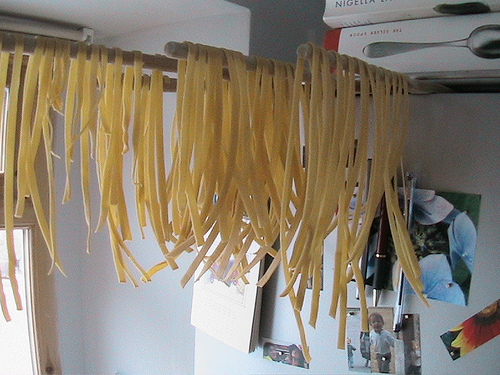<image>
Is the noodles on the bar? Yes. Looking at the image, I can see the noodles is positioned on top of the bar, with the bar providing support. Where is the noodles in relation to the wall pegs? Is it above the wall pegs? Yes. The noodles is positioned above the wall pegs in the vertical space, higher up in the scene. 